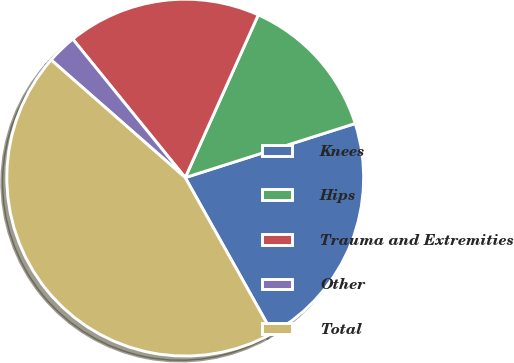Convert chart. <chart><loc_0><loc_0><loc_500><loc_500><pie_chart><fcel>Knees<fcel>Hips<fcel>Trauma and Extremities<fcel>Other<fcel>Total<nl><fcel>21.77%<fcel>13.38%<fcel>17.57%<fcel>2.68%<fcel>44.6%<nl></chart> 